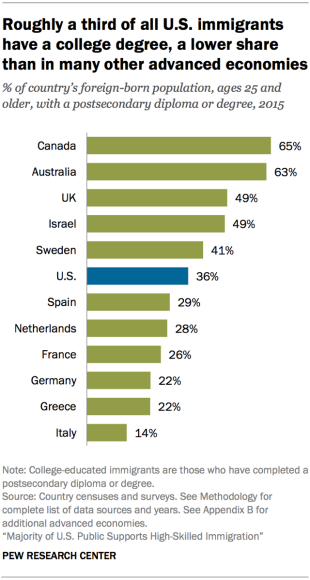Indicate a few pertinent items in this graphic. Out of the countries, how many have values greater than 40%? Canada ranks first in the chart. 